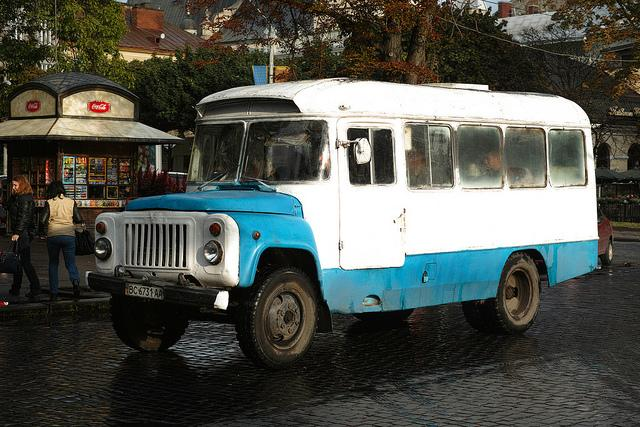What part of the bus needs good traction to ride safely? Please explain your reasoning. tires. These are what allow it to stop quickly if necessary and keep it from sliding in wet weather. 